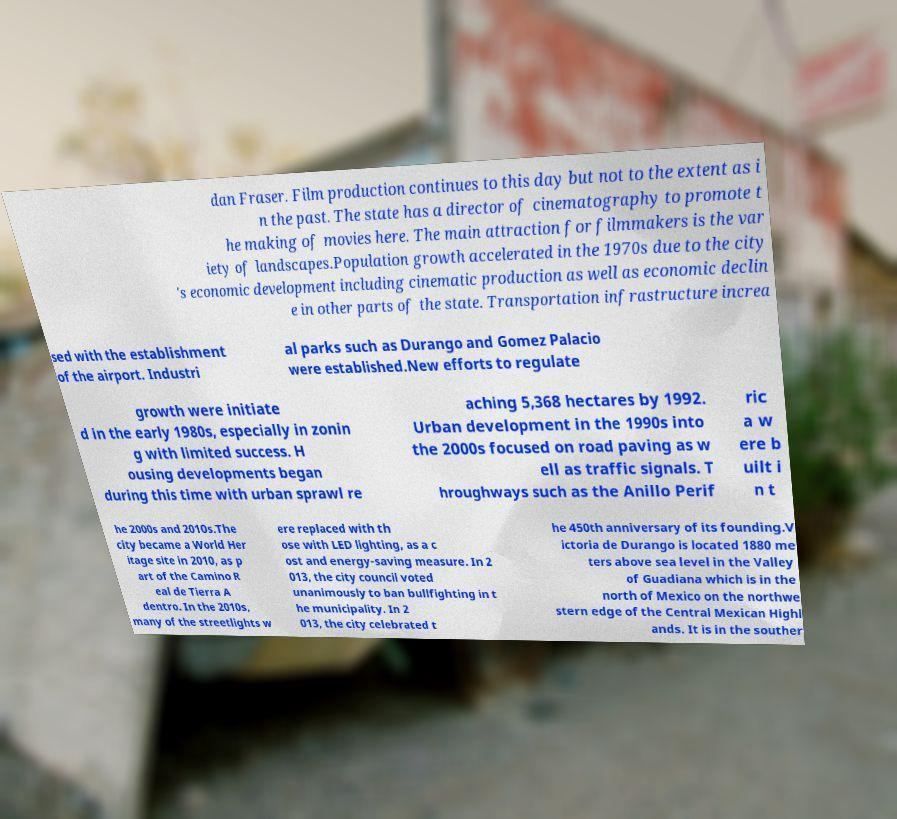Please read and relay the text visible in this image. What does it say? dan Fraser. Film production continues to this day but not to the extent as i n the past. The state has a director of cinematography to promote t he making of movies here. The main attraction for filmmakers is the var iety of landscapes.Population growth accelerated in the 1970s due to the city 's economic development including cinematic production as well as economic declin e in other parts of the state. Transportation infrastructure increa sed with the establishment of the airport. Industri al parks such as Durango and Gomez Palacio were established.New efforts to regulate growth were initiate d in the early 1980s, especially in zonin g with limited success. H ousing developments began during this time with urban sprawl re aching 5,368 hectares by 1992. Urban development in the 1990s into the 2000s focused on road paving as w ell as traffic signals. T hroughways such as the Anillo Perif ric a w ere b uilt i n t he 2000s and 2010s.The city became a World Her itage site in 2010, as p art of the Camino R eal de Tierra A dentro. In the 2010s, many of the streetlights w ere replaced with th ose with LED lighting, as a c ost and energy-saving measure. In 2 013, the city council voted unanimously to ban bullfighting in t he municipality. In 2 013, the city celebrated t he 450th anniversary of its founding.V ictoria de Durango is located 1880 me ters above sea level in the Valley of Guadiana which is in the north of Mexico on the northwe stern edge of the Central Mexican Highl ands. It is in the souther 